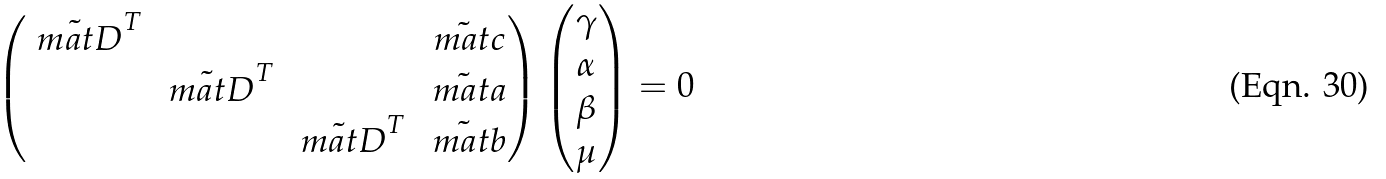Convert formula to latex. <formula><loc_0><loc_0><loc_500><loc_500>\begin{pmatrix} \tilde { \ m a t D } ^ { T } & & & \tilde { \ m a t c } \\ & \tilde { \ m a t D } ^ { T } & & \tilde { \ m a t a } \\ & & \tilde { \ m a t D } ^ { T } & \tilde { \ m a t b } \end{pmatrix} \begin{pmatrix} \gamma \\ \alpha \\ \beta \\ \mu \end{pmatrix} = 0</formula> 